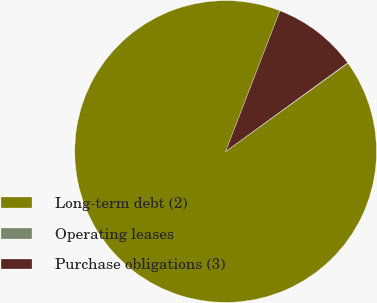Convert chart. <chart><loc_0><loc_0><loc_500><loc_500><pie_chart><fcel>Long-term debt (2)<fcel>Operating leases<fcel>Purchase obligations (3)<nl><fcel>90.82%<fcel>0.05%<fcel>9.13%<nl></chart> 